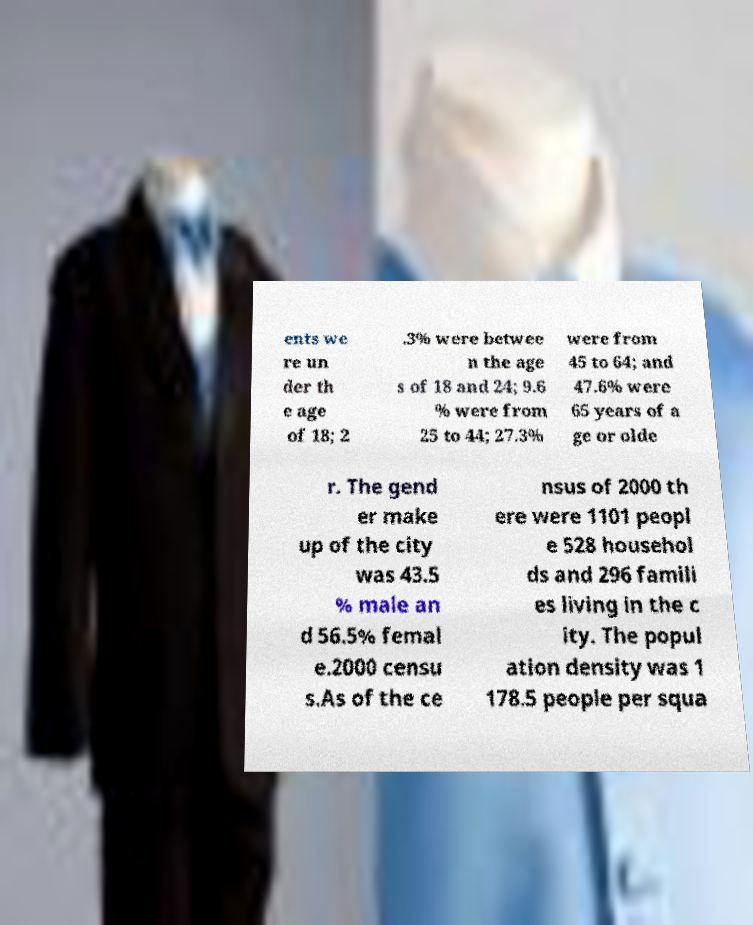Please identify and transcribe the text found in this image. ents we re un der th e age of 18; 2 .3% were betwee n the age s of 18 and 24; 9.6 % were from 25 to 44; 27.3% were from 45 to 64; and 47.6% were 65 years of a ge or olde r. The gend er make up of the city was 43.5 % male an d 56.5% femal e.2000 censu s.As of the ce nsus of 2000 th ere were 1101 peopl e 528 househol ds and 296 famili es living in the c ity. The popul ation density was 1 178.5 people per squa 